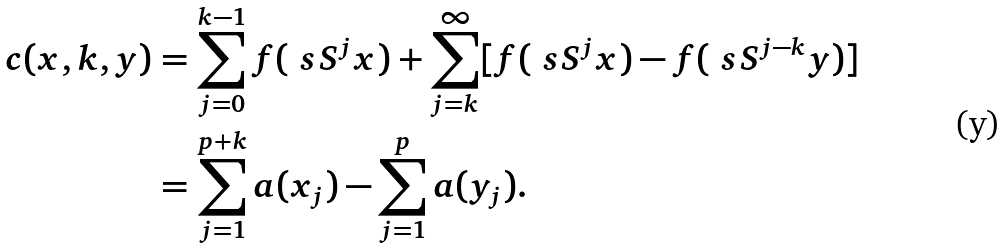<formula> <loc_0><loc_0><loc_500><loc_500>c ( x , k , y ) & = \sum _ { j = 0 } ^ { k - 1 } f ( \ s S ^ { j } x ) + \sum _ { j = k } ^ { \infty } [ f ( \ s S ^ { j } x ) - f ( \ s S ^ { j - k } y ) ] \\ & = \sum _ { j = 1 } ^ { p + k } a ( x _ { j } ) - \sum _ { j = 1 } ^ { p } a ( y _ { j } ) .</formula> 